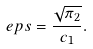Convert formula to latex. <formula><loc_0><loc_0><loc_500><loc_500>\ e p s = \frac { \sqrt { \pi _ { 2 } } } { c _ { 1 } } .</formula> 